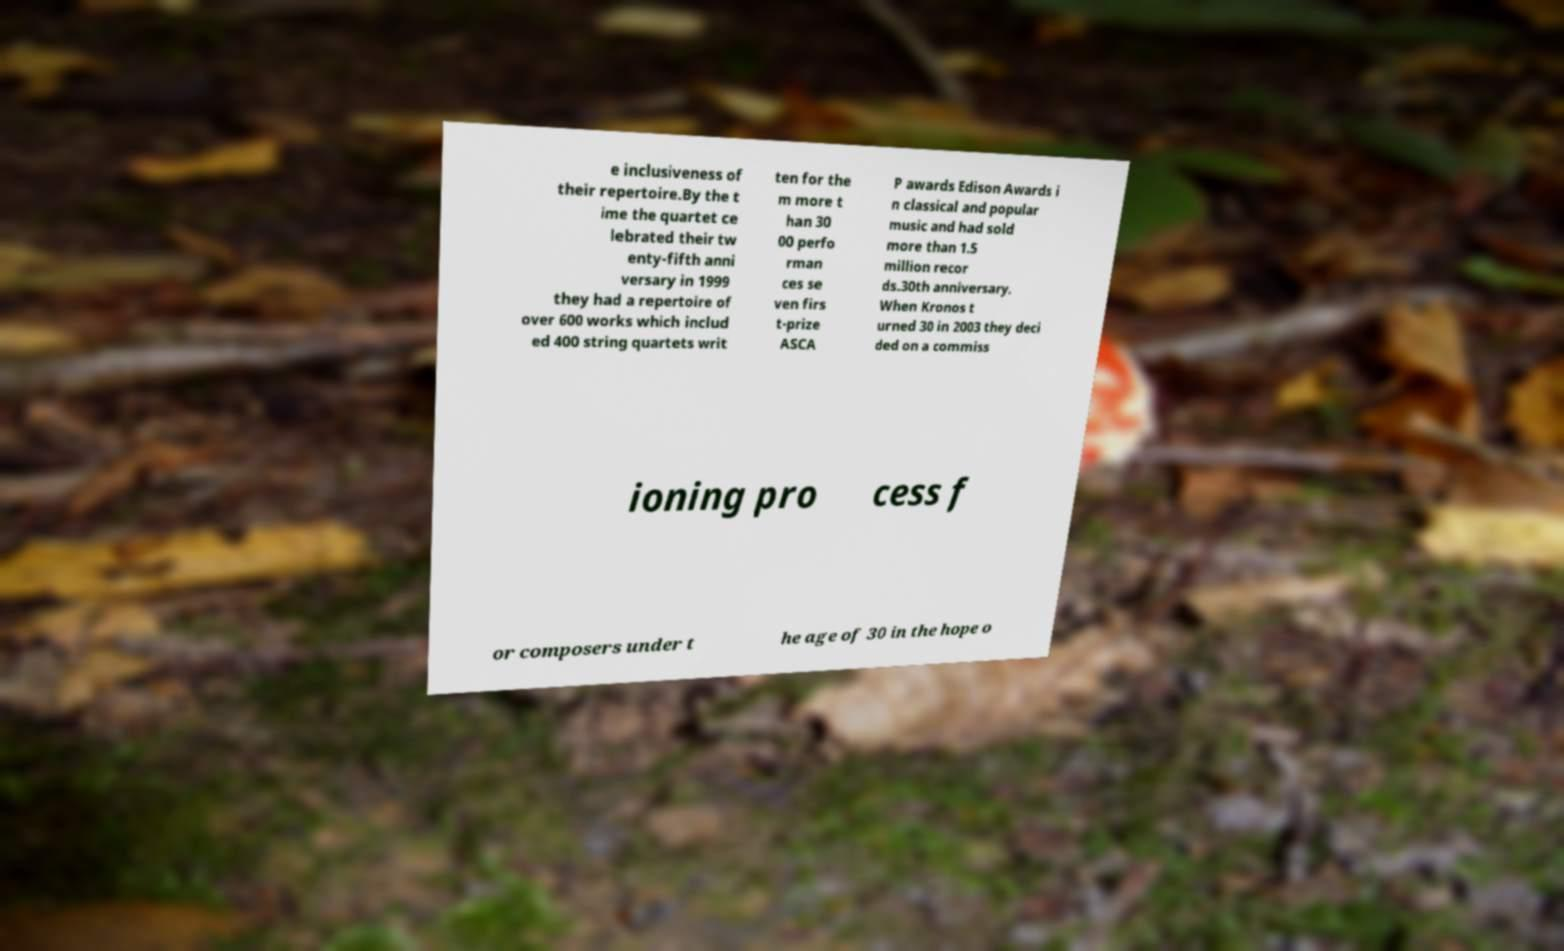Could you extract and type out the text from this image? e inclusiveness of their repertoire.By the t ime the quartet ce lebrated their tw enty-fifth anni versary in 1999 they had a repertoire of over 600 works which includ ed 400 string quartets writ ten for the m more t han 30 00 perfo rman ces se ven firs t-prize ASCA P awards Edison Awards i n classical and popular music and had sold more than 1.5 million recor ds.30th anniversary. When Kronos t urned 30 in 2003 they deci ded on a commiss ioning pro cess f or composers under t he age of 30 in the hope o 